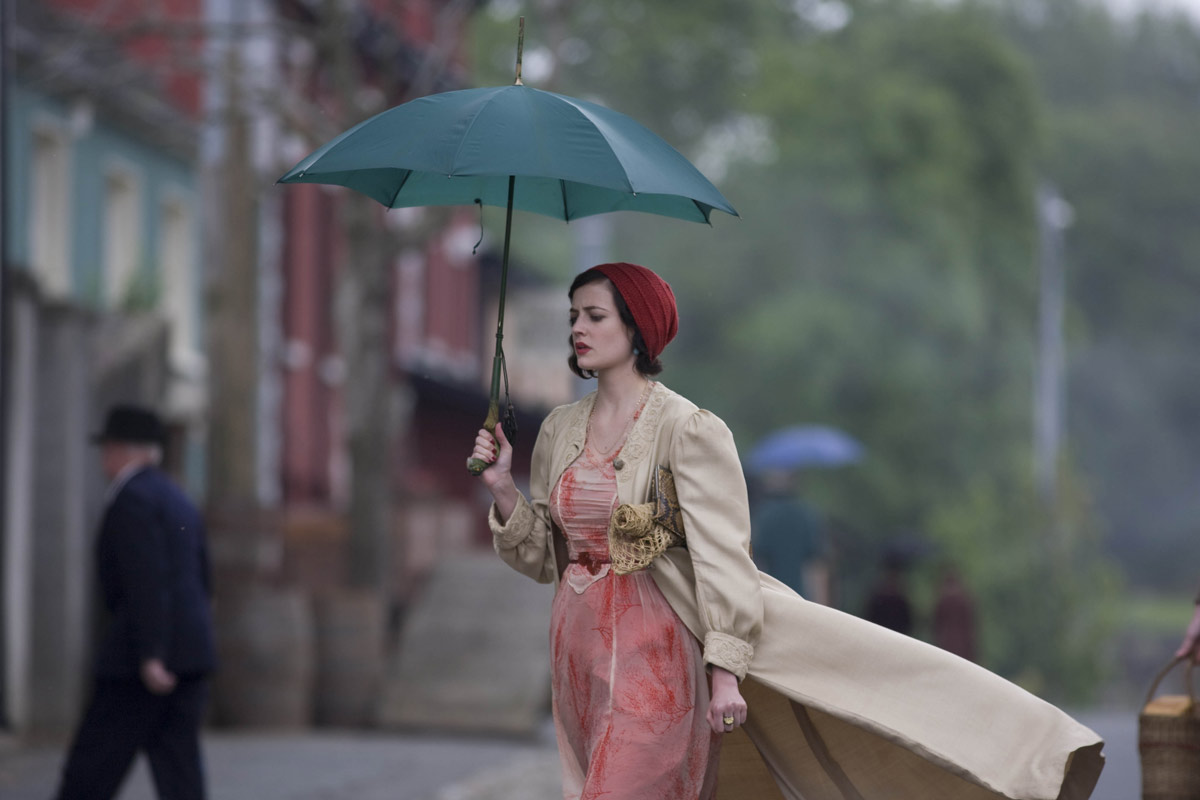What might the woman be contemplating as she walks down this street? The woman's contemplative expression and slow pace in the historical setting may suggest she's pondering a significant personal dilemma or reflecting on a momentous event that has occurred in her life. 